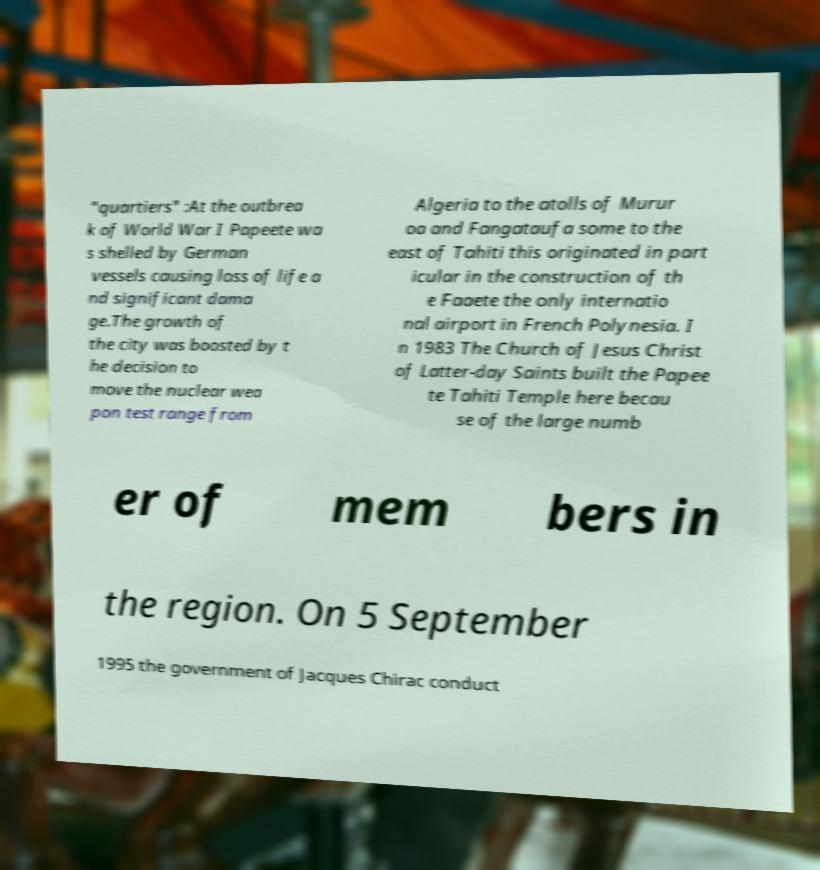For documentation purposes, I need the text within this image transcribed. Could you provide that? "quartiers" :At the outbrea k of World War I Papeete wa s shelled by German vessels causing loss of life a nd significant dama ge.The growth of the city was boosted by t he decision to move the nuclear wea pon test range from Algeria to the atolls of Murur oa and Fangataufa some to the east of Tahiti this originated in part icular in the construction of th e Faaete the only internatio nal airport in French Polynesia. I n 1983 The Church of Jesus Christ of Latter-day Saints built the Papee te Tahiti Temple here becau se of the large numb er of mem bers in the region. On 5 September 1995 the government of Jacques Chirac conduct 